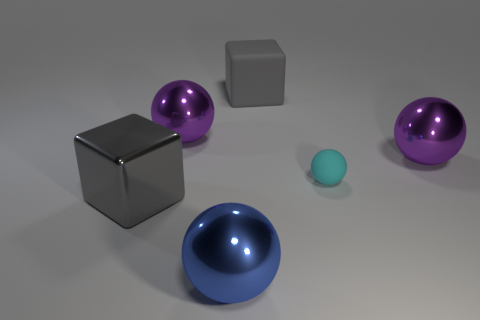Are there any other things that are the same size as the cyan sphere?
Ensure brevity in your answer.  No. What material is the other big object that is the same shape as the gray metal thing?
Provide a short and direct response. Rubber. There is a rubber ball; is it the same size as the sphere that is in front of the cyan object?
Offer a terse response. No. How many cylinders are either metallic things or big objects?
Make the answer very short. 0. What number of things are both in front of the matte ball and to the right of the small matte sphere?
Your answer should be very brief. 0. What number of other things are the same color as the rubber sphere?
Your response must be concise. 0. What shape is the metal object in front of the metallic cube?
Offer a terse response. Sphere. Does the tiny cyan ball have the same material as the large blue sphere?
Your response must be concise. No. What number of shiny objects are on the right side of the tiny sphere?
Ensure brevity in your answer.  1. There is a large purple shiny thing that is behind the large purple ball on the right side of the cyan rubber object; what is its shape?
Keep it short and to the point. Sphere. 